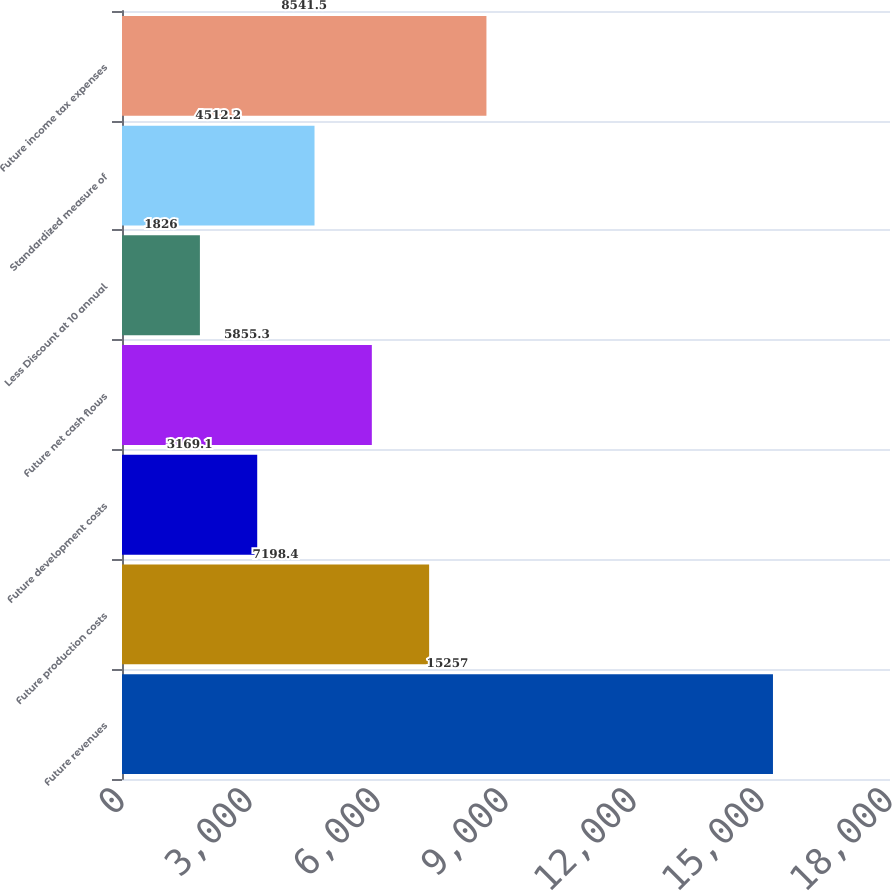Convert chart to OTSL. <chart><loc_0><loc_0><loc_500><loc_500><bar_chart><fcel>Future revenues<fcel>Future production costs<fcel>Future development costs<fcel>Future net cash flows<fcel>Less Discount at 10 annual<fcel>Standardized measure of<fcel>Future income tax expenses<nl><fcel>15257<fcel>7198.4<fcel>3169.1<fcel>5855.3<fcel>1826<fcel>4512.2<fcel>8541.5<nl></chart> 